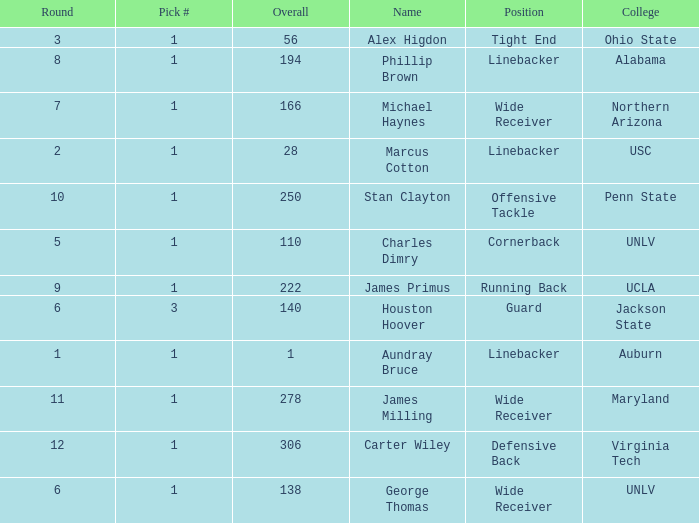In what Round was George Thomas Picked? 6.0. 